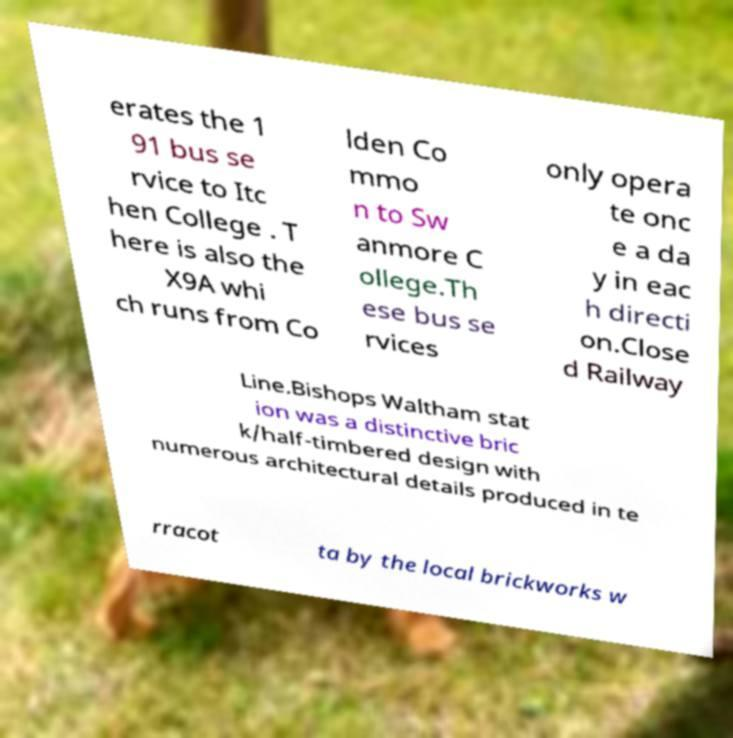Could you assist in decoding the text presented in this image and type it out clearly? erates the 1 91 bus se rvice to Itc hen College . T here is also the X9A whi ch runs from Co lden Co mmo n to Sw anmore C ollege.Th ese bus se rvices only opera te onc e a da y in eac h directi on.Close d Railway Line.Bishops Waltham stat ion was a distinctive bric k/half-timbered design with numerous architectural details produced in te rracot ta by the local brickworks w 